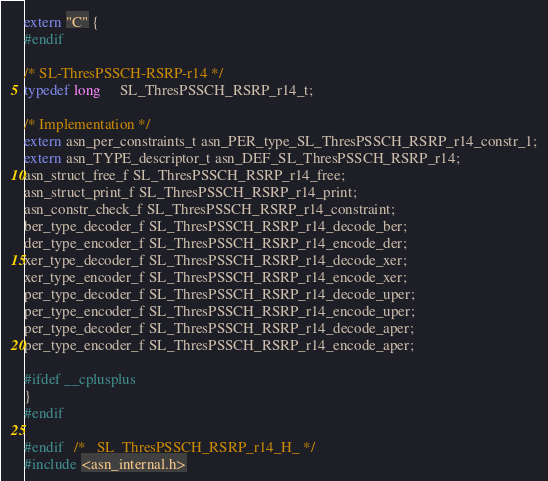<code> <loc_0><loc_0><loc_500><loc_500><_C_>extern "C" {
#endif

/* SL-ThresPSSCH-RSRP-r14 */
typedef long	 SL_ThresPSSCH_RSRP_r14_t;

/* Implementation */
extern asn_per_constraints_t asn_PER_type_SL_ThresPSSCH_RSRP_r14_constr_1;
extern asn_TYPE_descriptor_t asn_DEF_SL_ThresPSSCH_RSRP_r14;
asn_struct_free_f SL_ThresPSSCH_RSRP_r14_free;
asn_struct_print_f SL_ThresPSSCH_RSRP_r14_print;
asn_constr_check_f SL_ThresPSSCH_RSRP_r14_constraint;
ber_type_decoder_f SL_ThresPSSCH_RSRP_r14_decode_ber;
der_type_encoder_f SL_ThresPSSCH_RSRP_r14_encode_der;
xer_type_decoder_f SL_ThresPSSCH_RSRP_r14_decode_xer;
xer_type_encoder_f SL_ThresPSSCH_RSRP_r14_encode_xer;
per_type_decoder_f SL_ThresPSSCH_RSRP_r14_decode_uper;
per_type_encoder_f SL_ThresPSSCH_RSRP_r14_encode_uper;
per_type_decoder_f SL_ThresPSSCH_RSRP_r14_decode_aper;
per_type_encoder_f SL_ThresPSSCH_RSRP_r14_encode_aper;

#ifdef __cplusplus
}
#endif

#endif	/* _SL_ThresPSSCH_RSRP_r14_H_ */
#include <asn_internal.h>
</code> 